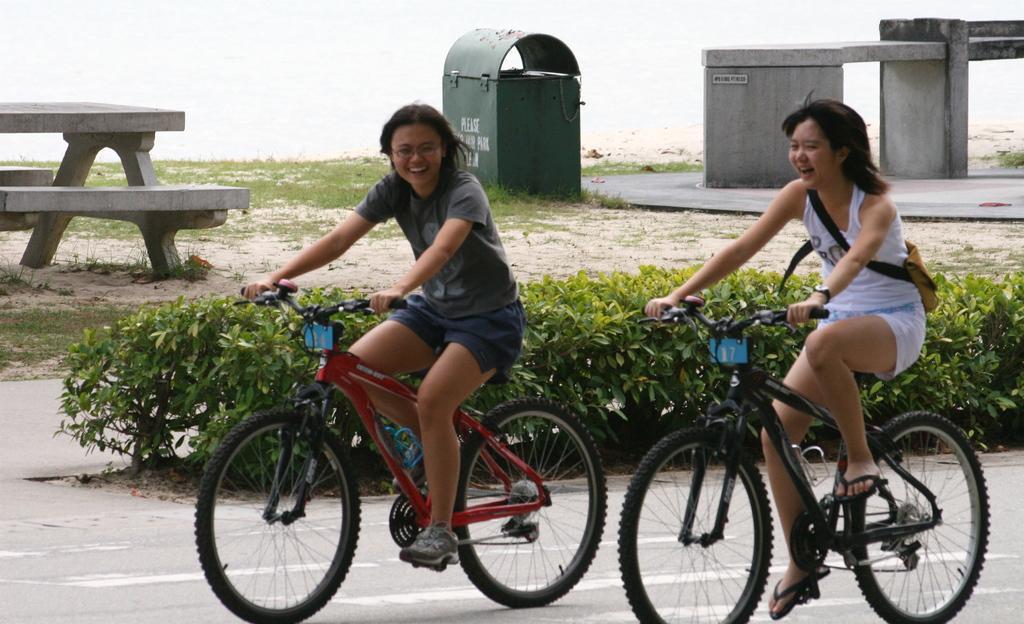In one or two sentences, can you explain what this image depicts? In this picture we can see there are two people riding the bicycles on the road. Behind the people there are plants, a bench, a dustbin and an architectural structure. 